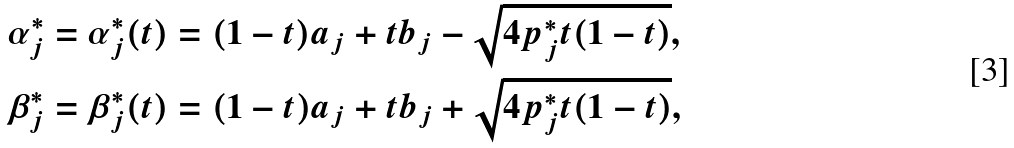<formula> <loc_0><loc_0><loc_500><loc_500>\alpha _ { j } ^ { * } & = \alpha _ { j } ^ { * } ( t ) = ( 1 - t ) a _ { j } + t b _ { j } - \sqrt { 4 p _ { j } ^ { * } t ( 1 - t ) } , \\ \beta _ { j } ^ { * } & = \beta _ { j } ^ { * } ( t ) = ( 1 - t ) a _ { j } + t b _ { j } + \sqrt { 4 p _ { j } ^ { * } t ( 1 - t ) } ,</formula> 